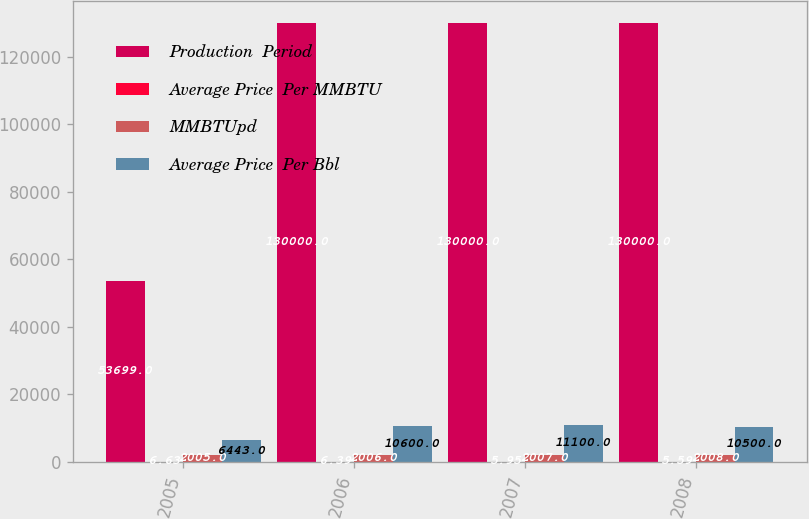<chart> <loc_0><loc_0><loc_500><loc_500><stacked_bar_chart><ecel><fcel>2005<fcel>2006<fcel>2007<fcel>2008<nl><fcel>Production  Period<fcel>53699<fcel>130000<fcel>130000<fcel>130000<nl><fcel>Average Price  Per MMBTU<fcel>6.63<fcel>6.39<fcel>5.95<fcel>5.59<nl><fcel>MMBTUpd<fcel>2005<fcel>2006<fcel>2007<fcel>2008<nl><fcel>Average Price  Per Bbl<fcel>6443<fcel>10600<fcel>11100<fcel>10500<nl></chart> 